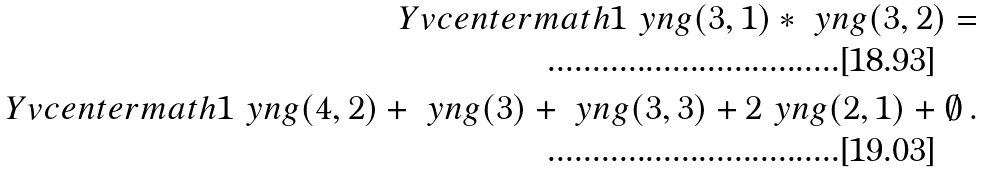<formula> <loc_0><loc_0><loc_500><loc_500>\ Y v c e n t e r m a t h 1 \ y n g ( 3 , 1 ) \ast \ y n g ( 3 , 2 ) = \\ \ Y v c e n t e r m a t h 1 \ y n g ( 4 , 2 ) + \ y n g ( 3 ) + \ y n g ( 3 , 3 ) + 2 \ y n g ( 2 , 1 ) + \emptyset \, .</formula> 